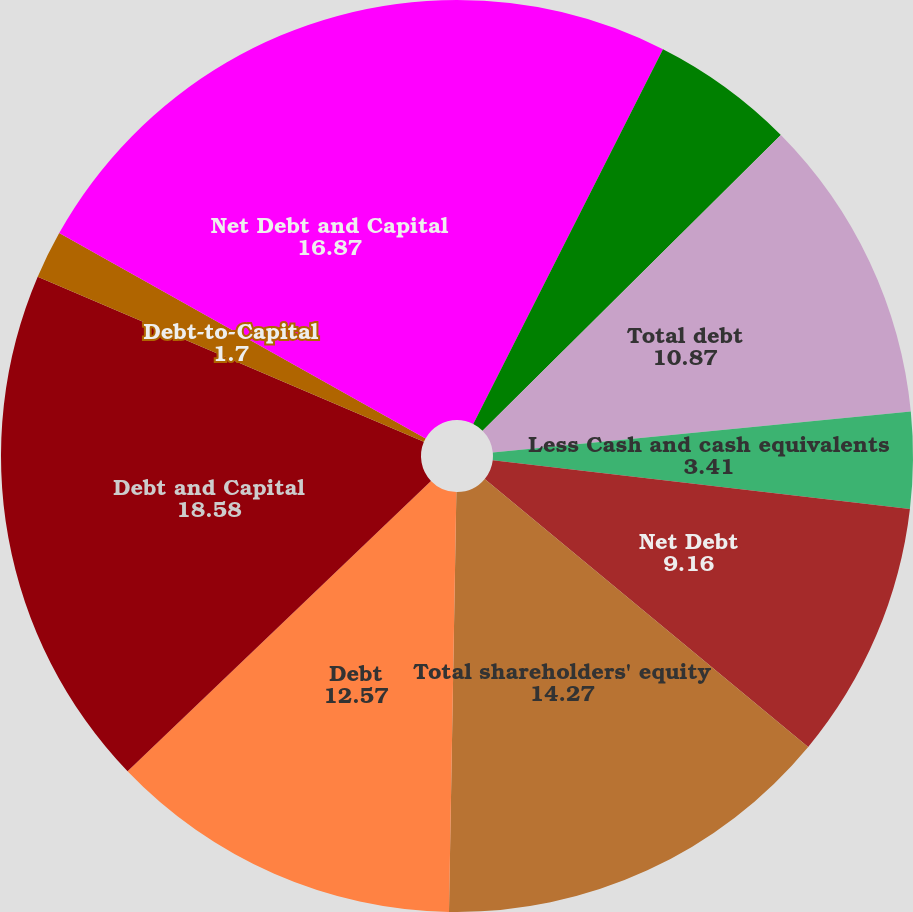Convert chart to OTSL. <chart><loc_0><loc_0><loc_500><loc_500><pie_chart><fcel>Long-term debtnet of current<fcel>Current portion of long-term<fcel>Total debt<fcel>Less Cash and cash equivalents<fcel>Net Debt<fcel>Total shareholders' equity<fcel>Debt<fcel>Debt and Capital<fcel>Debt-to-Capital<fcel>Net Debt and Capital<nl><fcel>7.46%<fcel>5.11%<fcel>10.87%<fcel>3.41%<fcel>9.16%<fcel>14.27%<fcel>12.57%<fcel>18.58%<fcel>1.7%<fcel>16.87%<nl></chart> 